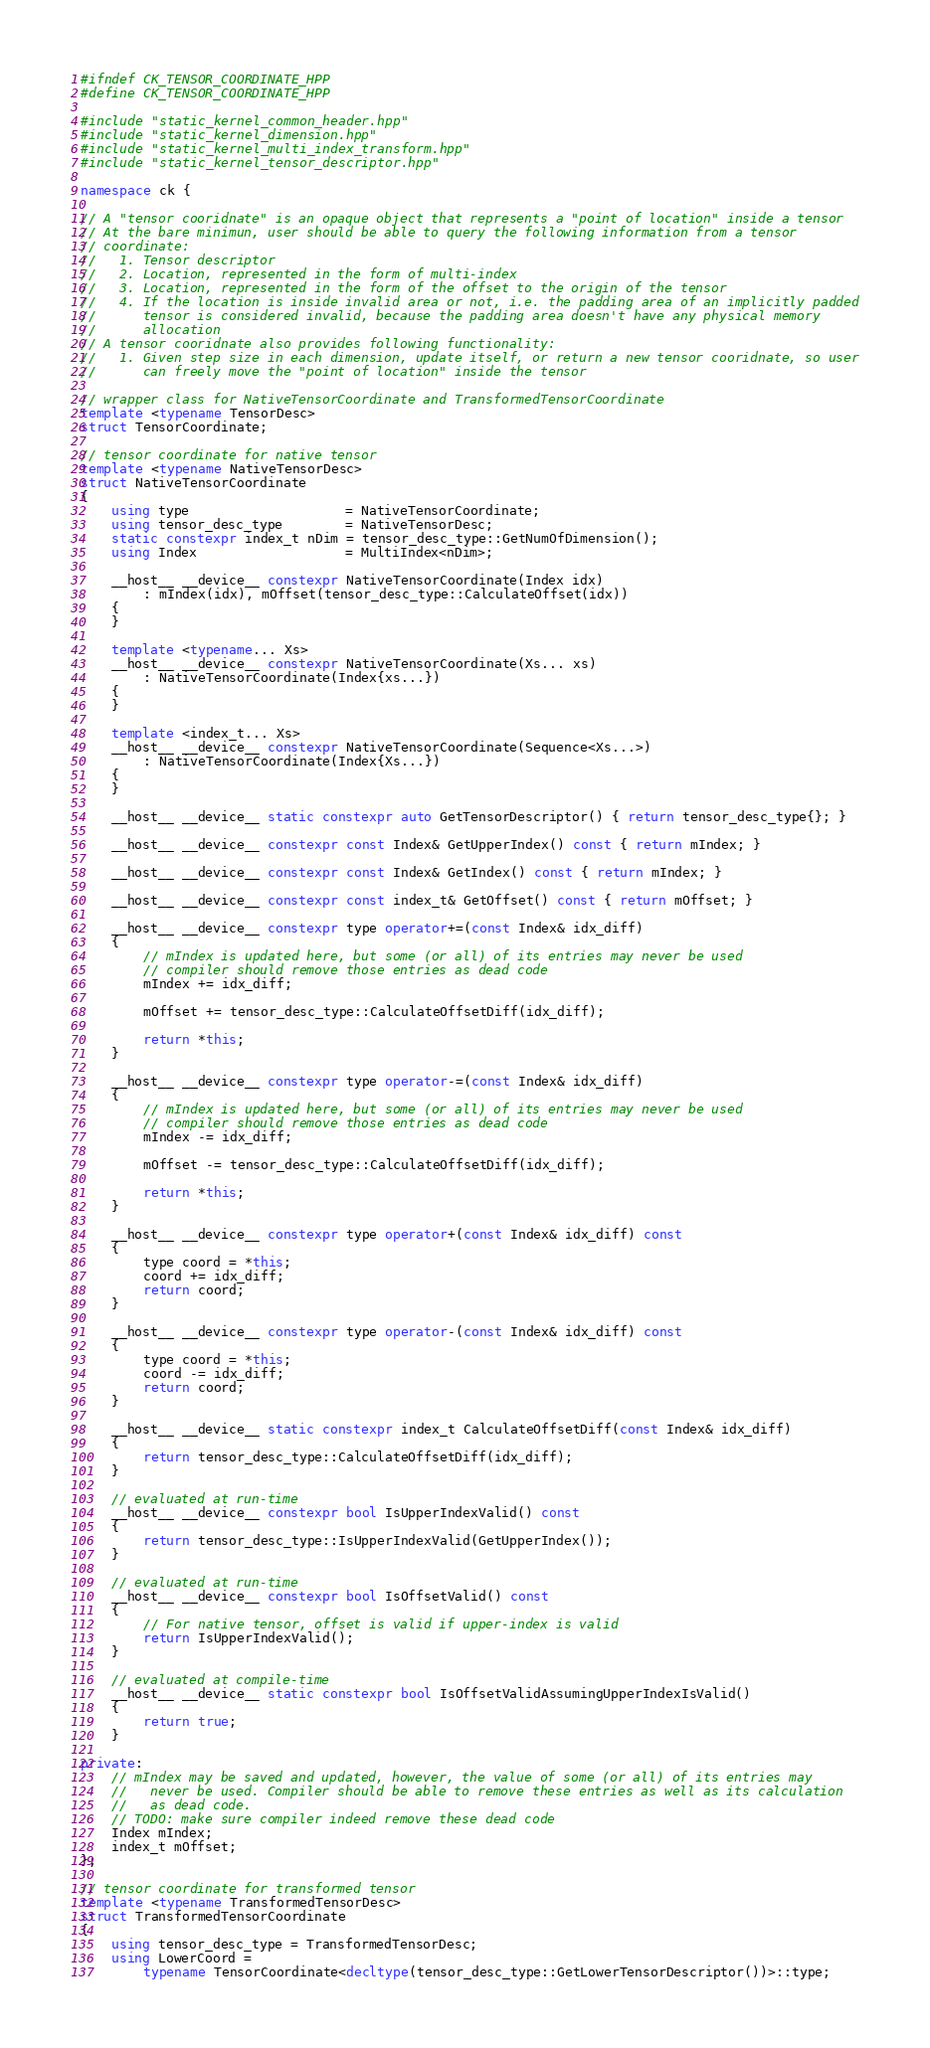<code> <loc_0><loc_0><loc_500><loc_500><_C++_>#ifndef CK_TENSOR_COORDINATE_HPP
#define CK_TENSOR_COORDINATE_HPP

#include "static_kernel_common_header.hpp"
#include "static_kernel_dimension.hpp"
#include "static_kernel_multi_index_transform.hpp"
#include "static_kernel_tensor_descriptor.hpp"

namespace ck {

// A "tensor cooridnate" is an opaque object that represents a "point of location" inside a tensor
// At the bare minimun, user should be able to query the following information from a tensor
// coordinate:
//   1. Tensor descriptor
//   2. Location, represented in the form of multi-index
//   3. Location, represented in the form of the offset to the origin of the tensor
//   4. If the location is inside invalid area or not, i.e. the padding area of an implicitly padded
//      tensor is considered invalid, because the padding area doesn't have any physical memory
//      allocation
// A tensor cooridnate also provides following functionality:
//   1. Given step size in each dimension, update itself, or return a new tensor cooridnate, so user
//      can freely move the "point of location" inside the tensor

// wrapper class for NativeTensorCoordinate and TransformedTensorCoordinate
template <typename TensorDesc>
struct TensorCoordinate;

// tensor coordinate for native tensor
template <typename NativeTensorDesc>
struct NativeTensorCoordinate
{
    using type                    = NativeTensorCoordinate;
    using tensor_desc_type        = NativeTensorDesc;
    static constexpr index_t nDim = tensor_desc_type::GetNumOfDimension();
    using Index                   = MultiIndex<nDim>;

    __host__ __device__ constexpr NativeTensorCoordinate(Index idx)
        : mIndex(idx), mOffset(tensor_desc_type::CalculateOffset(idx))
    {
    }

    template <typename... Xs>
    __host__ __device__ constexpr NativeTensorCoordinate(Xs... xs)
        : NativeTensorCoordinate(Index{xs...})
    {
    }

    template <index_t... Xs>
    __host__ __device__ constexpr NativeTensorCoordinate(Sequence<Xs...>)
        : NativeTensorCoordinate(Index{Xs...})
    {
    }

    __host__ __device__ static constexpr auto GetTensorDescriptor() { return tensor_desc_type{}; }

    __host__ __device__ constexpr const Index& GetUpperIndex() const { return mIndex; }

    __host__ __device__ constexpr const Index& GetIndex() const { return mIndex; }

    __host__ __device__ constexpr const index_t& GetOffset() const { return mOffset; }

    __host__ __device__ constexpr type operator+=(const Index& idx_diff)
    {
        // mIndex is updated here, but some (or all) of its entries may never be used
        // compiler should remove those entries as dead code
        mIndex += idx_diff;

        mOffset += tensor_desc_type::CalculateOffsetDiff(idx_diff);

        return *this;
    }

    __host__ __device__ constexpr type operator-=(const Index& idx_diff)
    {
        // mIndex is updated here, but some (or all) of its entries may never be used
        // compiler should remove those entries as dead code
        mIndex -= idx_diff;

        mOffset -= tensor_desc_type::CalculateOffsetDiff(idx_diff);

        return *this;
    }

    __host__ __device__ constexpr type operator+(const Index& idx_diff) const
    {
        type coord = *this;
        coord += idx_diff;
        return coord;
    }

    __host__ __device__ constexpr type operator-(const Index& idx_diff) const
    {
        type coord = *this;
        coord -= idx_diff;
        return coord;
    }

    __host__ __device__ static constexpr index_t CalculateOffsetDiff(const Index& idx_diff)
    {
        return tensor_desc_type::CalculateOffsetDiff(idx_diff);
    }

    // evaluated at run-time
    __host__ __device__ constexpr bool IsUpperIndexValid() const
    {
        return tensor_desc_type::IsUpperIndexValid(GetUpperIndex());
    }

    // evaluated at run-time
    __host__ __device__ constexpr bool IsOffsetValid() const
    {
        // For native tensor, offset is valid if upper-index is valid
        return IsUpperIndexValid();
    }

    // evaluated at compile-time
    __host__ __device__ static constexpr bool IsOffsetValidAssumingUpperIndexIsValid()
    {
        return true;
    }

private:
    // mIndex may be saved and updated, however, the value of some (or all) of its entries may
    //   never be used. Compiler should be able to remove these entries as well as its calculation
    //   as dead code.
    // TODO: make sure compiler indeed remove these dead code
    Index mIndex;
    index_t mOffset;
};

// tensor coordinate for transformed tensor
template <typename TransformedTensorDesc>
struct TransformedTensorCoordinate
{
    using tensor_desc_type = TransformedTensorDesc;
    using LowerCoord =
        typename TensorCoordinate<decltype(tensor_desc_type::GetLowerTensorDescriptor())>::type;</code> 